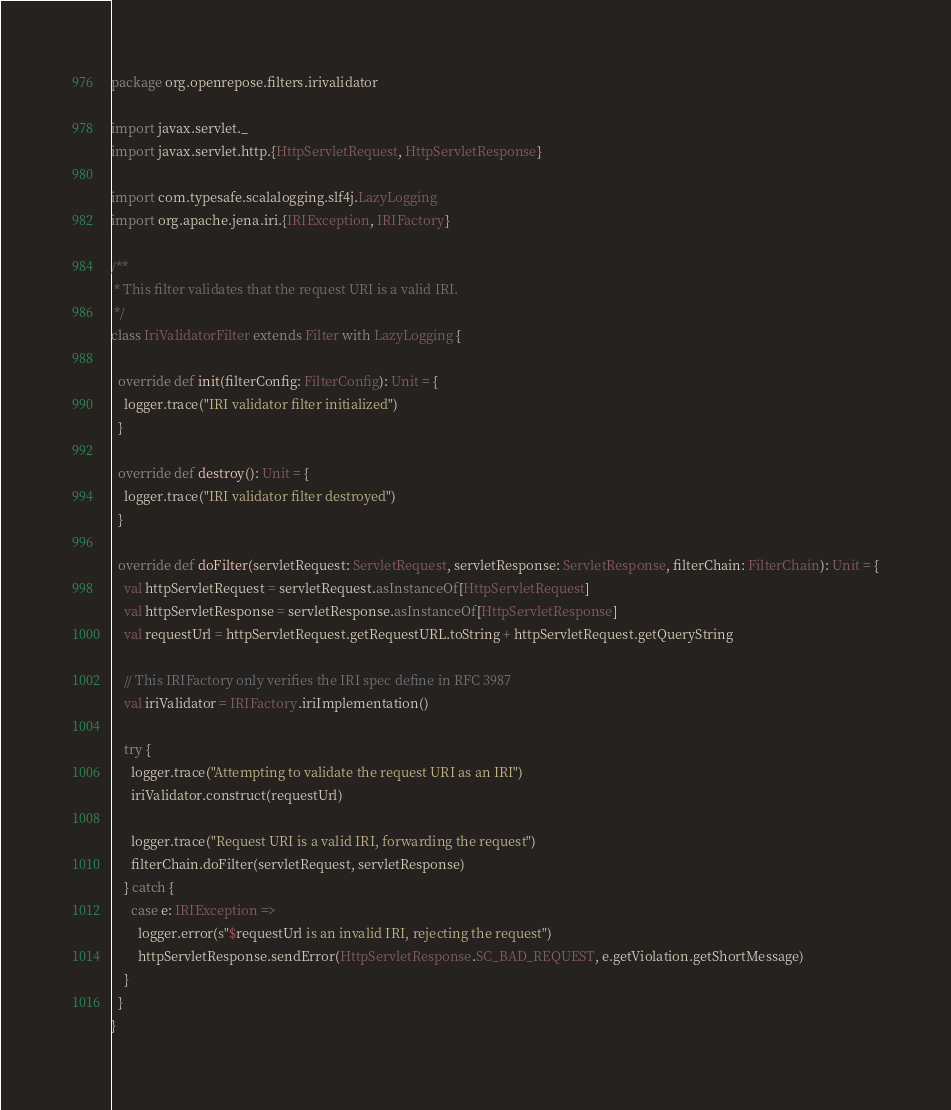Convert code to text. <code><loc_0><loc_0><loc_500><loc_500><_Scala_>package org.openrepose.filters.irivalidator

import javax.servlet._
import javax.servlet.http.{HttpServletRequest, HttpServletResponse}

import com.typesafe.scalalogging.slf4j.LazyLogging
import org.apache.jena.iri.{IRIException, IRIFactory}

/**
 * This filter validates that the request URI is a valid IRI.
 */
class IriValidatorFilter extends Filter with LazyLogging {

  override def init(filterConfig: FilterConfig): Unit = {
    logger.trace("IRI validator filter initialized")
  }

  override def destroy(): Unit = {
    logger.trace("IRI validator filter destroyed")
  }

  override def doFilter(servletRequest: ServletRequest, servletResponse: ServletResponse, filterChain: FilterChain): Unit = {
    val httpServletRequest = servletRequest.asInstanceOf[HttpServletRequest]
    val httpServletResponse = servletResponse.asInstanceOf[HttpServletResponse]
    val requestUrl = httpServletRequest.getRequestURL.toString + httpServletRequest.getQueryString

    // This IRIFactory only verifies the IRI spec define in RFC 3987
    val iriValidator = IRIFactory.iriImplementation()

    try {
      logger.trace("Attempting to validate the request URI as an IRI")
      iriValidator.construct(requestUrl)

      logger.trace("Request URI is a valid IRI, forwarding the request")
      filterChain.doFilter(servletRequest, servletResponse)
    } catch {
      case e: IRIException =>
        logger.error(s"$requestUrl is an invalid IRI, rejecting the request")
        httpServletResponse.sendError(HttpServletResponse.SC_BAD_REQUEST, e.getViolation.getShortMessage)
    }
  }
}
</code> 